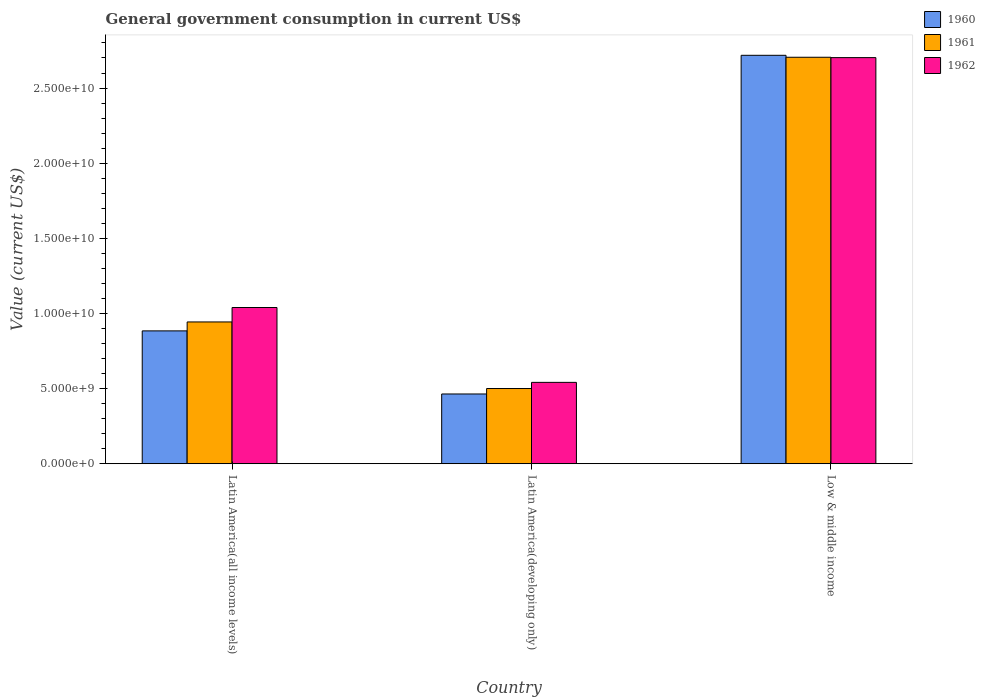How many groups of bars are there?
Ensure brevity in your answer.  3. Are the number of bars per tick equal to the number of legend labels?
Offer a very short reply. Yes. Are the number of bars on each tick of the X-axis equal?
Your response must be concise. Yes. In how many cases, is the number of bars for a given country not equal to the number of legend labels?
Your response must be concise. 0. What is the government conusmption in 1962 in Latin America(all income levels)?
Make the answer very short. 1.04e+1. Across all countries, what is the maximum government conusmption in 1960?
Offer a terse response. 2.72e+1. Across all countries, what is the minimum government conusmption in 1962?
Offer a terse response. 5.41e+09. In which country was the government conusmption in 1960 minimum?
Your answer should be very brief. Latin America(developing only). What is the total government conusmption in 1961 in the graph?
Provide a succinct answer. 4.15e+1. What is the difference between the government conusmption in 1962 in Latin America(all income levels) and that in Low & middle income?
Offer a very short reply. -1.66e+1. What is the difference between the government conusmption in 1962 in Latin America(all income levels) and the government conusmption in 1961 in Latin America(developing only)?
Your response must be concise. 5.39e+09. What is the average government conusmption in 1962 per country?
Provide a short and direct response. 1.43e+1. What is the difference between the government conusmption of/in 1960 and government conusmption of/in 1961 in Latin America(developing only)?
Make the answer very short. -3.63e+08. In how many countries, is the government conusmption in 1962 greater than 13000000000 US$?
Your answer should be very brief. 1. What is the ratio of the government conusmption in 1961 in Latin America(all income levels) to that in Low & middle income?
Give a very brief answer. 0.35. Is the difference between the government conusmption in 1960 in Latin America(all income levels) and Latin America(developing only) greater than the difference between the government conusmption in 1961 in Latin America(all income levels) and Latin America(developing only)?
Provide a short and direct response. No. What is the difference between the highest and the second highest government conusmption in 1962?
Your response must be concise. -4.98e+09. What is the difference between the highest and the lowest government conusmption in 1962?
Keep it short and to the point. 2.16e+1. In how many countries, is the government conusmption in 1961 greater than the average government conusmption in 1961 taken over all countries?
Offer a terse response. 1. What does the 3rd bar from the left in Low & middle income represents?
Make the answer very short. 1962. Is it the case that in every country, the sum of the government conusmption in 1961 and government conusmption in 1962 is greater than the government conusmption in 1960?
Your response must be concise. Yes. How many bars are there?
Offer a very short reply. 9. How many countries are there in the graph?
Give a very brief answer. 3. Does the graph contain any zero values?
Make the answer very short. No. Does the graph contain grids?
Your answer should be very brief. No. How many legend labels are there?
Give a very brief answer. 3. How are the legend labels stacked?
Your answer should be compact. Vertical. What is the title of the graph?
Offer a very short reply. General government consumption in current US$. Does "1981" appear as one of the legend labels in the graph?
Offer a very short reply. No. What is the label or title of the X-axis?
Your answer should be very brief. Country. What is the label or title of the Y-axis?
Your response must be concise. Value (current US$). What is the Value (current US$) in 1960 in Latin America(all income levels)?
Offer a terse response. 8.84e+09. What is the Value (current US$) of 1961 in Latin America(all income levels)?
Provide a short and direct response. 9.43e+09. What is the Value (current US$) in 1962 in Latin America(all income levels)?
Offer a very short reply. 1.04e+1. What is the Value (current US$) in 1960 in Latin America(developing only)?
Provide a succinct answer. 4.64e+09. What is the Value (current US$) of 1961 in Latin America(developing only)?
Keep it short and to the point. 5.01e+09. What is the Value (current US$) in 1962 in Latin America(developing only)?
Make the answer very short. 5.41e+09. What is the Value (current US$) in 1960 in Low & middle income?
Make the answer very short. 2.72e+1. What is the Value (current US$) of 1961 in Low & middle income?
Your answer should be compact. 2.70e+1. What is the Value (current US$) in 1962 in Low & middle income?
Your response must be concise. 2.70e+1. Across all countries, what is the maximum Value (current US$) of 1960?
Provide a succinct answer. 2.72e+1. Across all countries, what is the maximum Value (current US$) of 1961?
Make the answer very short. 2.70e+1. Across all countries, what is the maximum Value (current US$) of 1962?
Give a very brief answer. 2.70e+1. Across all countries, what is the minimum Value (current US$) of 1960?
Provide a short and direct response. 4.64e+09. Across all countries, what is the minimum Value (current US$) in 1961?
Your answer should be compact. 5.01e+09. Across all countries, what is the minimum Value (current US$) of 1962?
Provide a succinct answer. 5.41e+09. What is the total Value (current US$) in 1960 in the graph?
Your response must be concise. 4.07e+1. What is the total Value (current US$) in 1961 in the graph?
Keep it short and to the point. 4.15e+1. What is the total Value (current US$) of 1962 in the graph?
Keep it short and to the point. 4.28e+1. What is the difference between the Value (current US$) of 1960 in Latin America(all income levels) and that in Latin America(developing only)?
Your response must be concise. 4.20e+09. What is the difference between the Value (current US$) in 1961 in Latin America(all income levels) and that in Latin America(developing only)?
Make the answer very short. 4.43e+09. What is the difference between the Value (current US$) in 1962 in Latin America(all income levels) and that in Latin America(developing only)?
Keep it short and to the point. 4.98e+09. What is the difference between the Value (current US$) of 1960 in Latin America(all income levels) and that in Low & middle income?
Offer a very short reply. -1.83e+1. What is the difference between the Value (current US$) in 1961 in Latin America(all income levels) and that in Low & middle income?
Keep it short and to the point. -1.76e+1. What is the difference between the Value (current US$) of 1962 in Latin America(all income levels) and that in Low & middle income?
Your response must be concise. -1.66e+1. What is the difference between the Value (current US$) of 1960 in Latin America(developing only) and that in Low & middle income?
Provide a succinct answer. -2.25e+1. What is the difference between the Value (current US$) of 1961 in Latin America(developing only) and that in Low & middle income?
Your response must be concise. -2.20e+1. What is the difference between the Value (current US$) in 1962 in Latin America(developing only) and that in Low & middle income?
Give a very brief answer. -2.16e+1. What is the difference between the Value (current US$) in 1960 in Latin America(all income levels) and the Value (current US$) in 1961 in Latin America(developing only)?
Keep it short and to the point. 3.83e+09. What is the difference between the Value (current US$) of 1960 in Latin America(all income levels) and the Value (current US$) of 1962 in Latin America(developing only)?
Make the answer very short. 3.43e+09. What is the difference between the Value (current US$) in 1961 in Latin America(all income levels) and the Value (current US$) in 1962 in Latin America(developing only)?
Make the answer very short. 4.02e+09. What is the difference between the Value (current US$) in 1960 in Latin America(all income levels) and the Value (current US$) in 1961 in Low & middle income?
Ensure brevity in your answer.  -1.82e+1. What is the difference between the Value (current US$) of 1960 in Latin America(all income levels) and the Value (current US$) of 1962 in Low & middle income?
Provide a succinct answer. -1.82e+1. What is the difference between the Value (current US$) in 1961 in Latin America(all income levels) and the Value (current US$) in 1962 in Low & middle income?
Your answer should be compact. -1.76e+1. What is the difference between the Value (current US$) of 1960 in Latin America(developing only) and the Value (current US$) of 1961 in Low & middle income?
Keep it short and to the point. -2.24e+1. What is the difference between the Value (current US$) of 1960 in Latin America(developing only) and the Value (current US$) of 1962 in Low & middle income?
Offer a very short reply. -2.24e+1. What is the difference between the Value (current US$) in 1961 in Latin America(developing only) and the Value (current US$) in 1962 in Low & middle income?
Offer a very short reply. -2.20e+1. What is the average Value (current US$) of 1960 per country?
Your answer should be very brief. 1.36e+1. What is the average Value (current US$) in 1961 per country?
Give a very brief answer. 1.38e+1. What is the average Value (current US$) in 1962 per country?
Offer a terse response. 1.43e+1. What is the difference between the Value (current US$) of 1960 and Value (current US$) of 1961 in Latin America(all income levels)?
Offer a very short reply. -5.95e+08. What is the difference between the Value (current US$) in 1960 and Value (current US$) in 1962 in Latin America(all income levels)?
Make the answer very short. -1.56e+09. What is the difference between the Value (current US$) in 1961 and Value (current US$) in 1962 in Latin America(all income levels)?
Make the answer very short. -9.61e+08. What is the difference between the Value (current US$) in 1960 and Value (current US$) in 1961 in Latin America(developing only)?
Your response must be concise. -3.63e+08. What is the difference between the Value (current US$) of 1960 and Value (current US$) of 1962 in Latin America(developing only)?
Ensure brevity in your answer.  -7.72e+08. What is the difference between the Value (current US$) of 1961 and Value (current US$) of 1962 in Latin America(developing only)?
Give a very brief answer. -4.09e+08. What is the difference between the Value (current US$) in 1960 and Value (current US$) in 1961 in Low & middle income?
Provide a succinct answer. 1.30e+08. What is the difference between the Value (current US$) in 1960 and Value (current US$) in 1962 in Low & middle income?
Your answer should be very brief. 1.54e+08. What is the difference between the Value (current US$) of 1961 and Value (current US$) of 1962 in Low & middle income?
Ensure brevity in your answer.  2.38e+07. What is the ratio of the Value (current US$) of 1960 in Latin America(all income levels) to that in Latin America(developing only)?
Give a very brief answer. 1.9. What is the ratio of the Value (current US$) in 1961 in Latin America(all income levels) to that in Latin America(developing only)?
Your response must be concise. 1.88. What is the ratio of the Value (current US$) of 1962 in Latin America(all income levels) to that in Latin America(developing only)?
Your response must be concise. 1.92. What is the ratio of the Value (current US$) in 1960 in Latin America(all income levels) to that in Low & middle income?
Offer a very short reply. 0.33. What is the ratio of the Value (current US$) in 1961 in Latin America(all income levels) to that in Low & middle income?
Ensure brevity in your answer.  0.35. What is the ratio of the Value (current US$) in 1962 in Latin America(all income levels) to that in Low & middle income?
Your answer should be compact. 0.38. What is the ratio of the Value (current US$) of 1960 in Latin America(developing only) to that in Low & middle income?
Give a very brief answer. 0.17. What is the ratio of the Value (current US$) of 1961 in Latin America(developing only) to that in Low & middle income?
Provide a short and direct response. 0.19. What is the ratio of the Value (current US$) of 1962 in Latin America(developing only) to that in Low & middle income?
Your response must be concise. 0.2. What is the difference between the highest and the second highest Value (current US$) in 1960?
Keep it short and to the point. 1.83e+1. What is the difference between the highest and the second highest Value (current US$) of 1961?
Your answer should be compact. 1.76e+1. What is the difference between the highest and the second highest Value (current US$) in 1962?
Ensure brevity in your answer.  1.66e+1. What is the difference between the highest and the lowest Value (current US$) of 1960?
Offer a very short reply. 2.25e+1. What is the difference between the highest and the lowest Value (current US$) in 1961?
Ensure brevity in your answer.  2.20e+1. What is the difference between the highest and the lowest Value (current US$) in 1962?
Your response must be concise. 2.16e+1. 